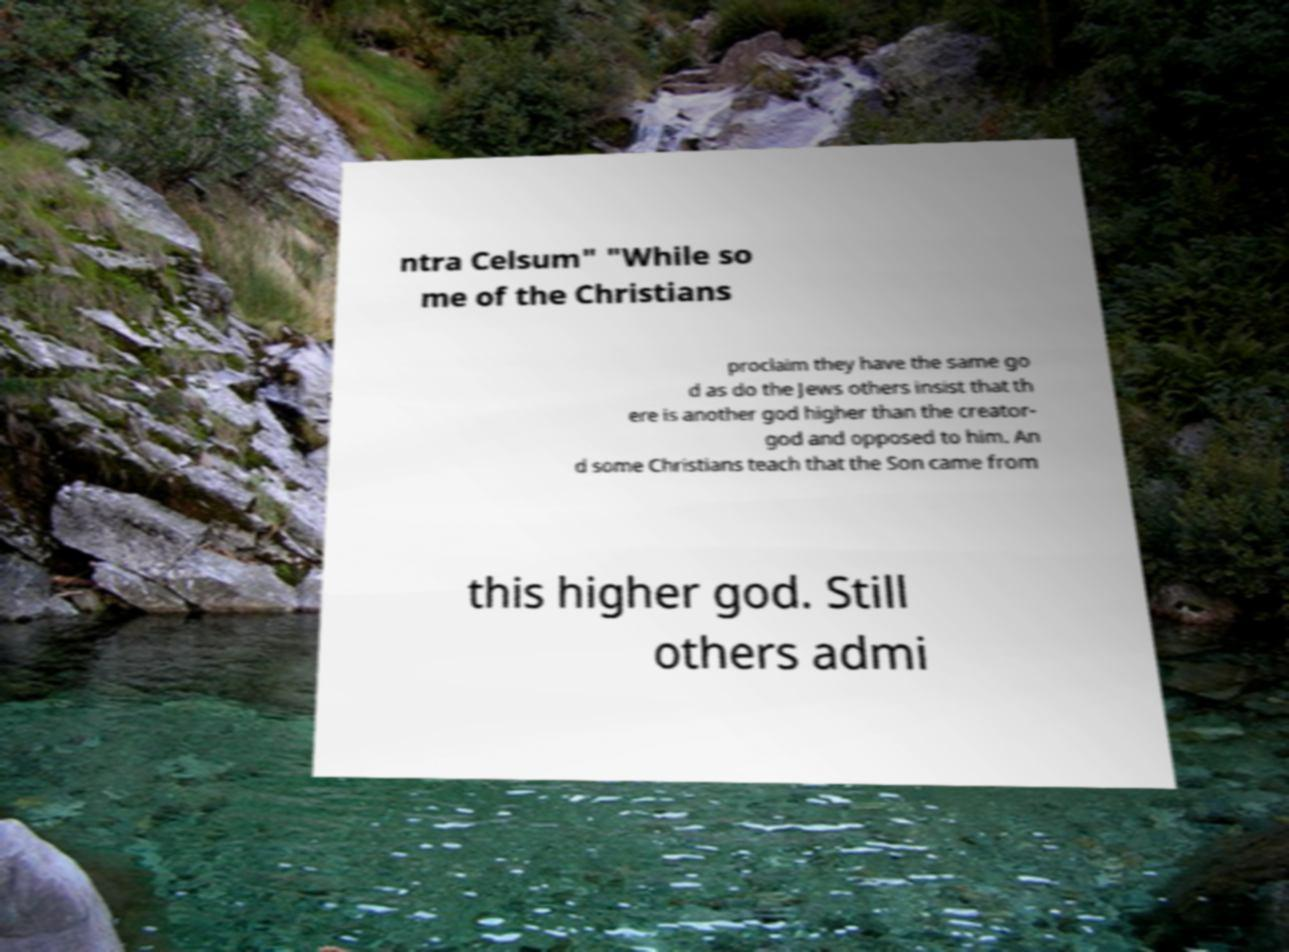There's text embedded in this image that I need extracted. Can you transcribe it verbatim? ntra Celsum" "While so me of the Christians proclaim they have the same go d as do the Jews others insist that th ere is another god higher than the creator- god and opposed to him. An d some Christians teach that the Son came from this higher god. Still others admi 